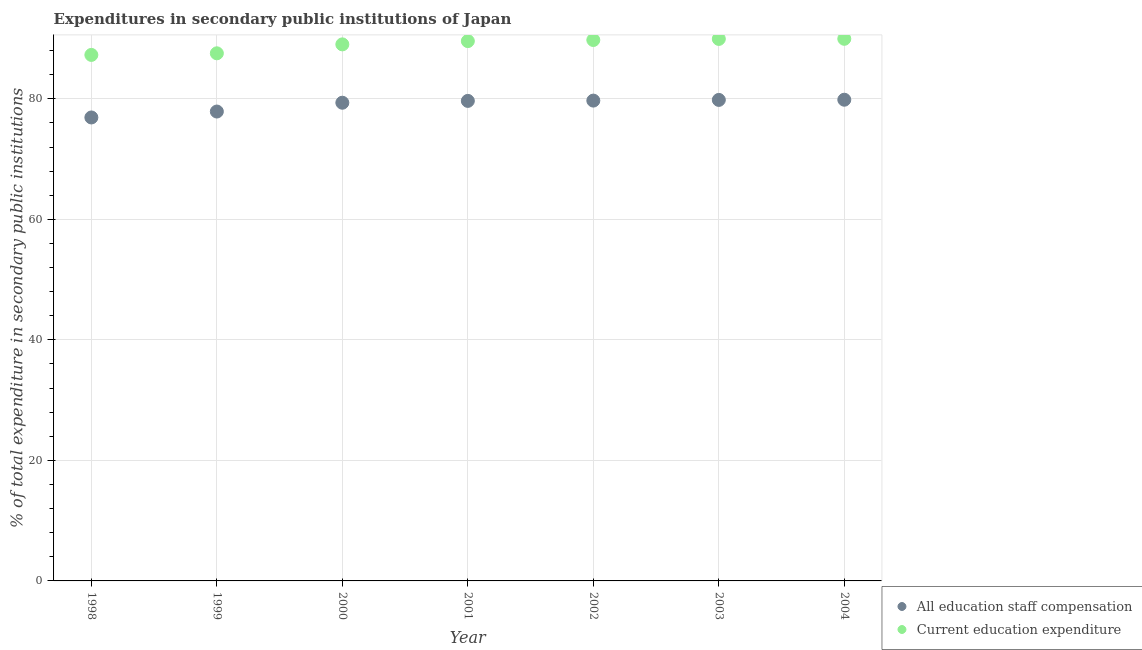What is the expenditure in education in 1999?
Keep it short and to the point. 87.56. Across all years, what is the maximum expenditure in staff compensation?
Offer a very short reply. 79.85. Across all years, what is the minimum expenditure in education?
Provide a short and direct response. 87.29. In which year was the expenditure in staff compensation maximum?
Provide a short and direct response. 2004. What is the total expenditure in education in the graph?
Provide a succinct answer. 623.14. What is the difference between the expenditure in education in 1999 and that in 2001?
Ensure brevity in your answer.  -2.02. What is the difference between the expenditure in staff compensation in 1999 and the expenditure in education in 2002?
Offer a terse response. -11.87. What is the average expenditure in staff compensation per year?
Offer a very short reply. 79.03. In the year 2001, what is the difference between the expenditure in education and expenditure in staff compensation?
Provide a succinct answer. 9.92. What is the ratio of the expenditure in staff compensation in 2002 to that in 2003?
Your answer should be very brief. 1. Is the difference between the expenditure in education in 2002 and 2003 greater than the difference between the expenditure in staff compensation in 2002 and 2003?
Your answer should be compact. No. What is the difference between the highest and the second highest expenditure in education?
Your answer should be very brief. 0.02. What is the difference between the highest and the lowest expenditure in staff compensation?
Ensure brevity in your answer.  2.94. Is the sum of the expenditure in staff compensation in 2001 and 2004 greater than the maximum expenditure in education across all years?
Keep it short and to the point. Yes. Does the expenditure in education monotonically increase over the years?
Offer a very short reply. Yes. Is the expenditure in education strictly less than the expenditure in staff compensation over the years?
Keep it short and to the point. No. Does the graph contain any zero values?
Offer a terse response. No. How many legend labels are there?
Provide a succinct answer. 2. What is the title of the graph?
Provide a short and direct response. Expenditures in secondary public institutions of Japan. What is the label or title of the Y-axis?
Offer a terse response. % of total expenditure in secondary public institutions. What is the % of total expenditure in secondary public institutions in All education staff compensation in 1998?
Your answer should be very brief. 76.91. What is the % of total expenditure in secondary public institutions in Current education expenditure in 1998?
Offer a very short reply. 87.29. What is the % of total expenditure in secondary public institutions of All education staff compensation in 1999?
Provide a succinct answer. 77.89. What is the % of total expenditure in secondary public institutions in Current education expenditure in 1999?
Provide a succinct answer. 87.56. What is the % of total expenditure in secondary public institutions of All education staff compensation in 2000?
Your answer should be compact. 79.36. What is the % of total expenditure in secondary public institutions of Current education expenditure in 2000?
Give a very brief answer. 89.04. What is the % of total expenditure in secondary public institutions in All education staff compensation in 2001?
Keep it short and to the point. 79.66. What is the % of total expenditure in secondary public institutions of Current education expenditure in 2001?
Ensure brevity in your answer.  89.58. What is the % of total expenditure in secondary public institutions in All education staff compensation in 2002?
Offer a terse response. 79.71. What is the % of total expenditure in secondary public institutions of Current education expenditure in 2002?
Your answer should be compact. 89.76. What is the % of total expenditure in secondary public institutions in All education staff compensation in 2003?
Provide a short and direct response. 79.82. What is the % of total expenditure in secondary public institutions of Current education expenditure in 2003?
Your response must be concise. 89.94. What is the % of total expenditure in secondary public institutions of All education staff compensation in 2004?
Give a very brief answer. 79.85. What is the % of total expenditure in secondary public institutions in Current education expenditure in 2004?
Your answer should be very brief. 89.96. Across all years, what is the maximum % of total expenditure in secondary public institutions in All education staff compensation?
Make the answer very short. 79.85. Across all years, what is the maximum % of total expenditure in secondary public institutions in Current education expenditure?
Keep it short and to the point. 89.96. Across all years, what is the minimum % of total expenditure in secondary public institutions of All education staff compensation?
Offer a very short reply. 76.91. Across all years, what is the minimum % of total expenditure in secondary public institutions in Current education expenditure?
Your response must be concise. 87.29. What is the total % of total expenditure in secondary public institutions in All education staff compensation in the graph?
Keep it short and to the point. 553.21. What is the total % of total expenditure in secondary public institutions in Current education expenditure in the graph?
Your answer should be very brief. 623.14. What is the difference between the % of total expenditure in secondary public institutions in All education staff compensation in 1998 and that in 1999?
Your answer should be compact. -0.98. What is the difference between the % of total expenditure in secondary public institutions in Current education expenditure in 1998 and that in 1999?
Provide a succinct answer. -0.27. What is the difference between the % of total expenditure in secondary public institutions in All education staff compensation in 1998 and that in 2000?
Provide a succinct answer. -2.44. What is the difference between the % of total expenditure in secondary public institutions of Current education expenditure in 1998 and that in 2000?
Your answer should be very brief. -1.75. What is the difference between the % of total expenditure in secondary public institutions in All education staff compensation in 1998 and that in 2001?
Provide a succinct answer. -2.75. What is the difference between the % of total expenditure in secondary public institutions of Current education expenditure in 1998 and that in 2001?
Your answer should be compact. -2.29. What is the difference between the % of total expenditure in secondary public institutions of All education staff compensation in 1998 and that in 2002?
Your response must be concise. -2.8. What is the difference between the % of total expenditure in secondary public institutions of Current education expenditure in 1998 and that in 2002?
Make the answer very short. -2.47. What is the difference between the % of total expenditure in secondary public institutions of All education staff compensation in 1998 and that in 2003?
Provide a short and direct response. -2.91. What is the difference between the % of total expenditure in secondary public institutions in Current education expenditure in 1998 and that in 2003?
Provide a short and direct response. -2.65. What is the difference between the % of total expenditure in secondary public institutions of All education staff compensation in 1998 and that in 2004?
Offer a very short reply. -2.94. What is the difference between the % of total expenditure in secondary public institutions of Current education expenditure in 1998 and that in 2004?
Your answer should be very brief. -2.67. What is the difference between the % of total expenditure in secondary public institutions of All education staff compensation in 1999 and that in 2000?
Your answer should be very brief. -1.46. What is the difference between the % of total expenditure in secondary public institutions of Current education expenditure in 1999 and that in 2000?
Ensure brevity in your answer.  -1.48. What is the difference between the % of total expenditure in secondary public institutions in All education staff compensation in 1999 and that in 2001?
Your response must be concise. -1.77. What is the difference between the % of total expenditure in secondary public institutions in Current education expenditure in 1999 and that in 2001?
Offer a very short reply. -2.02. What is the difference between the % of total expenditure in secondary public institutions of All education staff compensation in 1999 and that in 2002?
Your response must be concise. -1.81. What is the difference between the % of total expenditure in secondary public institutions in Current education expenditure in 1999 and that in 2002?
Keep it short and to the point. -2.21. What is the difference between the % of total expenditure in secondary public institutions of All education staff compensation in 1999 and that in 2003?
Your answer should be compact. -1.93. What is the difference between the % of total expenditure in secondary public institutions of Current education expenditure in 1999 and that in 2003?
Keep it short and to the point. -2.39. What is the difference between the % of total expenditure in secondary public institutions of All education staff compensation in 1999 and that in 2004?
Provide a short and direct response. -1.96. What is the difference between the % of total expenditure in secondary public institutions in Current education expenditure in 1999 and that in 2004?
Your response must be concise. -2.41. What is the difference between the % of total expenditure in secondary public institutions in All education staff compensation in 2000 and that in 2001?
Offer a very short reply. -0.3. What is the difference between the % of total expenditure in secondary public institutions of Current education expenditure in 2000 and that in 2001?
Provide a succinct answer. -0.54. What is the difference between the % of total expenditure in secondary public institutions in All education staff compensation in 2000 and that in 2002?
Your response must be concise. -0.35. What is the difference between the % of total expenditure in secondary public institutions of Current education expenditure in 2000 and that in 2002?
Provide a succinct answer. -0.73. What is the difference between the % of total expenditure in secondary public institutions in All education staff compensation in 2000 and that in 2003?
Offer a very short reply. -0.47. What is the difference between the % of total expenditure in secondary public institutions in Current education expenditure in 2000 and that in 2003?
Offer a very short reply. -0.91. What is the difference between the % of total expenditure in secondary public institutions in All education staff compensation in 2000 and that in 2004?
Offer a very short reply. -0.5. What is the difference between the % of total expenditure in secondary public institutions in Current education expenditure in 2000 and that in 2004?
Ensure brevity in your answer.  -0.92. What is the difference between the % of total expenditure in secondary public institutions in All education staff compensation in 2001 and that in 2002?
Your answer should be compact. -0.05. What is the difference between the % of total expenditure in secondary public institutions in Current education expenditure in 2001 and that in 2002?
Offer a terse response. -0.18. What is the difference between the % of total expenditure in secondary public institutions of All education staff compensation in 2001 and that in 2003?
Give a very brief answer. -0.16. What is the difference between the % of total expenditure in secondary public institutions in Current education expenditure in 2001 and that in 2003?
Offer a terse response. -0.36. What is the difference between the % of total expenditure in secondary public institutions in All education staff compensation in 2001 and that in 2004?
Offer a very short reply. -0.19. What is the difference between the % of total expenditure in secondary public institutions of Current education expenditure in 2001 and that in 2004?
Your answer should be very brief. -0.38. What is the difference between the % of total expenditure in secondary public institutions in All education staff compensation in 2002 and that in 2003?
Your answer should be compact. -0.11. What is the difference between the % of total expenditure in secondary public institutions in Current education expenditure in 2002 and that in 2003?
Your answer should be very brief. -0.18. What is the difference between the % of total expenditure in secondary public institutions in All education staff compensation in 2002 and that in 2004?
Provide a succinct answer. -0.15. What is the difference between the % of total expenditure in secondary public institutions in Current education expenditure in 2002 and that in 2004?
Offer a terse response. -0.2. What is the difference between the % of total expenditure in secondary public institutions of All education staff compensation in 2003 and that in 2004?
Your answer should be very brief. -0.03. What is the difference between the % of total expenditure in secondary public institutions in Current education expenditure in 2003 and that in 2004?
Keep it short and to the point. -0.02. What is the difference between the % of total expenditure in secondary public institutions in All education staff compensation in 1998 and the % of total expenditure in secondary public institutions in Current education expenditure in 1999?
Offer a terse response. -10.65. What is the difference between the % of total expenditure in secondary public institutions of All education staff compensation in 1998 and the % of total expenditure in secondary public institutions of Current education expenditure in 2000?
Offer a very short reply. -12.13. What is the difference between the % of total expenditure in secondary public institutions of All education staff compensation in 1998 and the % of total expenditure in secondary public institutions of Current education expenditure in 2001?
Offer a terse response. -12.67. What is the difference between the % of total expenditure in secondary public institutions in All education staff compensation in 1998 and the % of total expenditure in secondary public institutions in Current education expenditure in 2002?
Your answer should be compact. -12.85. What is the difference between the % of total expenditure in secondary public institutions of All education staff compensation in 1998 and the % of total expenditure in secondary public institutions of Current education expenditure in 2003?
Provide a succinct answer. -13.03. What is the difference between the % of total expenditure in secondary public institutions in All education staff compensation in 1998 and the % of total expenditure in secondary public institutions in Current education expenditure in 2004?
Your answer should be very brief. -13.05. What is the difference between the % of total expenditure in secondary public institutions in All education staff compensation in 1999 and the % of total expenditure in secondary public institutions in Current education expenditure in 2000?
Give a very brief answer. -11.14. What is the difference between the % of total expenditure in secondary public institutions in All education staff compensation in 1999 and the % of total expenditure in secondary public institutions in Current education expenditure in 2001?
Your response must be concise. -11.69. What is the difference between the % of total expenditure in secondary public institutions of All education staff compensation in 1999 and the % of total expenditure in secondary public institutions of Current education expenditure in 2002?
Provide a succinct answer. -11.87. What is the difference between the % of total expenditure in secondary public institutions in All education staff compensation in 1999 and the % of total expenditure in secondary public institutions in Current education expenditure in 2003?
Keep it short and to the point. -12.05. What is the difference between the % of total expenditure in secondary public institutions of All education staff compensation in 1999 and the % of total expenditure in secondary public institutions of Current education expenditure in 2004?
Ensure brevity in your answer.  -12.07. What is the difference between the % of total expenditure in secondary public institutions in All education staff compensation in 2000 and the % of total expenditure in secondary public institutions in Current education expenditure in 2001?
Your answer should be compact. -10.23. What is the difference between the % of total expenditure in secondary public institutions of All education staff compensation in 2000 and the % of total expenditure in secondary public institutions of Current education expenditure in 2002?
Offer a very short reply. -10.41. What is the difference between the % of total expenditure in secondary public institutions of All education staff compensation in 2000 and the % of total expenditure in secondary public institutions of Current education expenditure in 2003?
Your answer should be compact. -10.59. What is the difference between the % of total expenditure in secondary public institutions in All education staff compensation in 2000 and the % of total expenditure in secondary public institutions in Current education expenditure in 2004?
Give a very brief answer. -10.61. What is the difference between the % of total expenditure in secondary public institutions of All education staff compensation in 2001 and the % of total expenditure in secondary public institutions of Current education expenditure in 2002?
Offer a terse response. -10.1. What is the difference between the % of total expenditure in secondary public institutions in All education staff compensation in 2001 and the % of total expenditure in secondary public institutions in Current education expenditure in 2003?
Offer a very short reply. -10.28. What is the difference between the % of total expenditure in secondary public institutions of All education staff compensation in 2001 and the % of total expenditure in secondary public institutions of Current education expenditure in 2004?
Offer a terse response. -10.3. What is the difference between the % of total expenditure in secondary public institutions in All education staff compensation in 2002 and the % of total expenditure in secondary public institutions in Current education expenditure in 2003?
Offer a terse response. -10.24. What is the difference between the % of total expenditure in secondary public institutions of All education staff compensation in 2002 and the % of total expenditure in secondary public institutions of Current education expenditure in 2004?
Make the answer very short. -10.26. What is the difference between the % of total expenditure in secondary public institutions of All education staff compensation in 2003 and the % of total expenditure in secondary public institutions of Current education expenditure in 2004?
Offer a terse response. -10.14. What is the average % of total expenditure in secondary public institutions of All education staff compensation per year?
Provide a succinct answer. 79.03. What is the average % of total expenditure in secondary public institutions in Current education expenditure per year?
Give a very brief answer. 89.02. In the year 1998, what is the difference between the % of total expenditure in secondary public institutions of All education staff compensation and % of total expenditure in secondary public institutions of Current education expenditure?
Give a very brief answer. -10.38. In the year 1999, what is the difference between the % of total expenditure in secondary public institutions of All education staff compensation and % of total expenditure in secondary public institutions of Current education expenditure?
Give a very brief answer. -9.66. In the year 2000, what is the difference between the % of total expenditure in secondary public institutions of All education staff compensation and % of total expenditure in secondary public institutions of Current education expenditure?
Ensure brevity in your answer.  -9.68. In the year 2001, what is the difference between the % of total expenditure in secondary public institutions of All education staff compensation and % of total expenditure in secondary public institutions of Current education expenditure?
Provide a short and direct response. -9.92. In the year 2002, what is the difference between the % of total expenditure in secondary public institutions of All education staff compensation and % of total expenditure in secondary public institutions of Current education expenditure?
Your answer should be compact. -10.06. In the year 2003, what is the difference between the % of total expenditure in secondary public institutions in All education staff compensation and % of total expenditure in secondary public institutions in Current education expenditure?
Provide a succinct answer. -10.12. In the year 2004, what is the difference between the % of total expenditure in secondary public institutions of All education staff compensation and % of total expenditure in secondary public institutions of Current education expenditure?
Your response must be concise. -10.11. What is the ratio of the % of total expenditure in secondary public institutions of All education staff compensation in 1998 to that in 1999?
Keep it short and to the point. 0.99. What is the ratio of the % of total expenditure in secondary public institutions of Current education expenditure in 1998 to that in 1999?
Your answer should be compact. 1. What is the ratio of the % of total expenditure in secondary public institutions in All education staff compensation in 1998 to that in 2000?
Your answer should be very brief. 0.97. What is the ratio of the % of total expenditure in secondary public institutions in Current education expenditure in 1998 to that in 2000?
Your response must be concise. 0.98. What is the ratio of the % of total expenditure in secondary public institutions of All education staff compensation in 1998 to that in 2001?
Give a very brief answer. 0.97. What is the ratio of the % of total expenditure in secondary public institutions in Current education expenditure in 1998 to that in 2001?
Offer a terse response. 0.97. What is the ratio of the % of total expenditure in secondary public institutions in All education staff compensation in 1998 to that in 2002?
Provide a succinct answer. 0.96. What is the ratio of the % of total expenditure in secondary public institutions of Current education expenditure in 1998 to that in 2002?
Your response must be concise. 0.97. What is the ratio of the % of total expenditure in secondary public institutions of All education staff compensation in 1998 to that in 2003?
Provide a succinct answer. 0.96. What is the ratio of the % of total expenditure in secondary public institutions of Current education expenditure in 1998 to that in 2003?
Your response must be concise. 0.97. What is the ratio of the % of total expenditure in secondary public institutions of All education staff compensation in 1998 to that in 2004?
Offer a terse response. 0.96. What is the ratio of the % of total expenditure in secondary public institutions of Current education expenditure in 1998 to that in 2004?
Your answer should be very brief. 0.97. What is the ratio of the % of total expenditure in secondary public institutions in All education staff compensation in 1999 to that in 2000?
Offer a very short reply. 0.98. What is the ratio of the % of total expenditure in secondary public institutions in Current education expenditure in 1999 to that in 2000?
Make the answer very short. 0.98. What is the ratio of the % of total expenditure in secondary public institutions of All education staff compensation in 1999 to that in 2001?
Your response must be concise. 0.98. What is the ratio of the % of total expenditure in secondary public institutions of Current education expenditure in 1999 to that in 2001?
Make the answer very short. 0.98. What is the ratio of the % of total expenditure in secondary public institutions of All education staff compensation in 1999 to that in 2002?
Provide a succinct answer. 0.98. What is the ratio of the % of total expenditure in secondary public institutions in Current education expenditure in 1999 to that in 2002?
Give a very brief answer. 0.98. What is the ratio of the % of total expenditure in secondary public institutions of All education staff compensation in 1999 to that in 2003?
Offer a very short reply. 0.98. What is the ratio of the % of total expenditure in secondary public institutions of Current education expenditure in 1999 to that in 2003?
Your answer should be very brief. 0.97. What is the ratio of the % of total expenditure in secondary public institutions of All education staff compensation in 1999 to that in 2004?
Keep it short and to the point. 0.98. What is the ratio of the % of total expenditure in secondary public institutions in Current education expenditure in 1999 to that in 2004?
Give a very brief answer. 0.97. What is the ratio of the % of total expenditure in secondary public institutions in Current education expenditure in 2000 to that in 2001?
Provide a short and direct response. 0.99. What is the ratio of the % of total expenditure in secondary public institutions of All education staff compensation in 2000 to that in 2002?
Offer a terse response. 1. What is the ratio of the % of total expenditure in secondary public institutions of Current education expenditure in 2000 to that in 2002?
Give a very brief answer. 0.99. What is the ratio of the % of total expenditure in secondary public institutions of All education staff compensation in 2000 to that in 2003?
Provide a succinct answer. 0.99. What is the ratio of the % of total expenditure in secondary public institutions in Current education expenditure in 2000 to that in 2004?
Give a very brief answer. 0.99. What is the ratio of the % of total expenditure in secondary public institutions of All education staff compensation in 2001 to that in 2002?
Your answer should be compact. 1. What is the ratio of the % of total expenditure in secondary public institutions in All education staff compensation in 2001 to that in 2004?
Your answer should be compact. 1. What is the ratio of the % of total expenditure in secondary public institutions in Current education expenditure in 2001 to that in 2004?
Your answer should be compact. 1. What is the ratio of the % of total expenditure in secondary public institutions in Current education expenditure in 2002 to that in 2003?
Keep it short and to the point. 1. What is the ratio of the % of total expenditure in secondary public institutions of All education staff compensation in 2002 to that in 2004?
Make the answer very short. 1. What is the ratio of the % of total expenditure in secondary public institutions in All education staff compensation in 2003 to that in 2004?
Provide a succinct answer. 1. What is the difference between the highest and the second highest % of total expenditure in secondary public institutions of All education staff compensation?
Give a very brief answer. 0.03. What is the difference between the highest and the second highest % of total expenditure in secondary public institutions of Current education expenditure?
Provide a short and direct response. 0.02. What is the difference between the highest and the lowest % of total expenditure in secondary public institutions of All education staff compensation?
Provide a short and direct response. 2.94. What is the difference between the highest and the lowest % of total expenditure in secondary public institutions in Current education expenditure?
Your answer should be very brief. 2.67. 